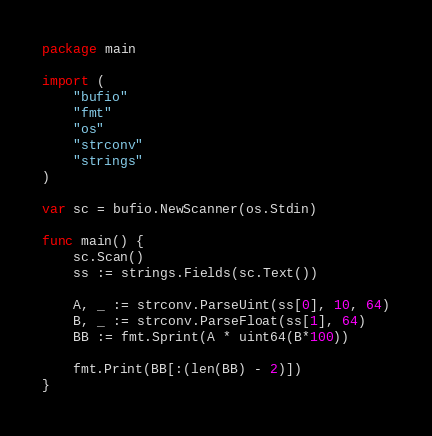Convert code to text. <code><loc_0><loc_0><loc_500><loc_500><_Go_>package main

import (
	"bufio"
	"fmt"
	"os"
	"strconv"
	"strings"
)

var sc = bufio.NewScanner(os.Stdin)

func main() {
	sc.Scan()
	ss := strings.Fields(sc.Text())

	A, _ := strconv.ParseUint(ss[0], 10, 64)
	B, _ := strconv.ParseFloat(ss[1], 64)
	BB := fmt.Sprint(A * uint64(B*100))

	fmt.Print(BB[:(len(BB) - 2)])
}
</code> 